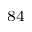<formula> <loc_0><loc_0><loc_500><loc_500>^ { 8 4 }</formula> 